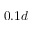<formula> <loc_0><loc_0><loc_500><loc_500>0 . 1 d</formula> 